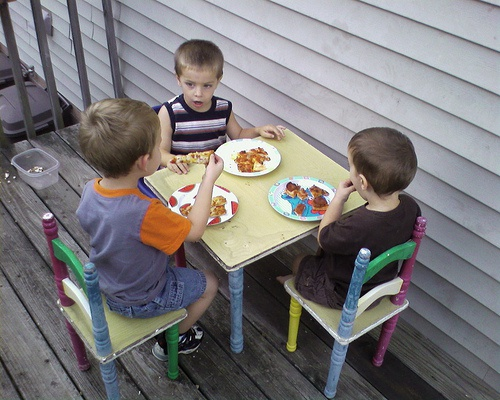Describe the objects in this image and their specific colors. I can see people in maroon, gray, red, and black tones, dining table in maroon, beige, ivory, darkgray, and gray tones, people in maroon, black, gray, and tan tones, chair in maroon, black, darkgray, and gray tones, and people in maroon, black, darkgray, and gray tones in this image. 